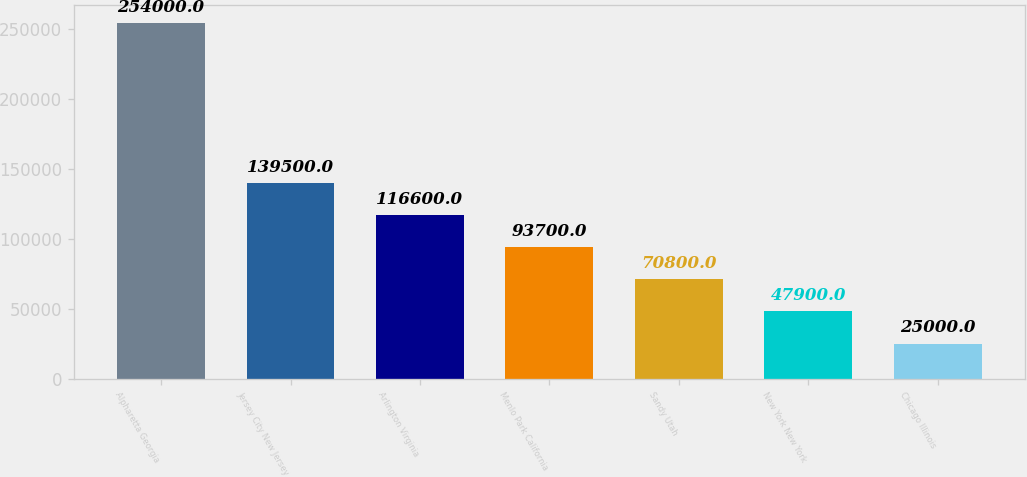<chart> <loc_0><loc_0><loc_500><loc_500><bar_chart><fcel>Alpharetta Georgia<fcel>Jersey City New Jersey<fcel>Arlington Virginia<fcel>Menlo Park California<fcel>Sandy Utah<fcel>New York New York<fcel>Chicago Illinois<nl><fcel>254000<fcel>139500<fcel>116600<fcel>93700<fcel>70800<fcel>47900<fcel>25000<nl></chart> 